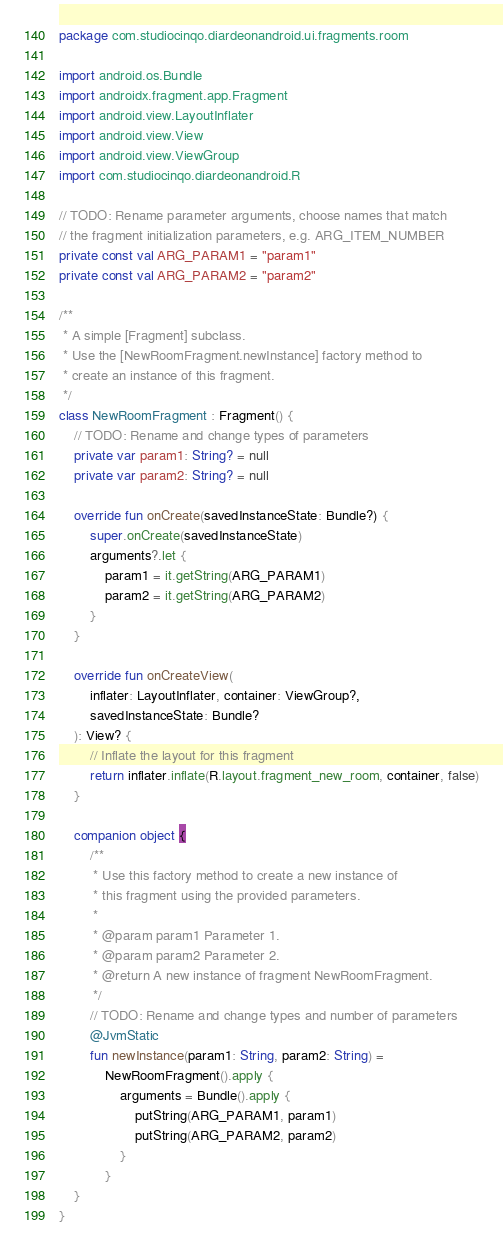Convert code to text. <code><loc_0><loc_0><loc_500><loc_500><_Kotlin_>package com.studiocinqo.diardeonandroid.ui.fragments.room

import android.os.Bundle
import androidx.fragment.app.Fragment
import android.view.LayoutInflater
import android.view.View
import android.view.ViewGroup
import com.studiocinqo.diardeonandroid.R

// TODO: Rename parameter arguments, choose names that match
// the fragment initialization parameters, e.g. ARG_ITEM_NUMBER
private const val ARG_PARAM1 = "param1"
private const val ARG_PARAM2 = "param2"

/**
 * A simple [Fragment] subclass.
 * Use the [NewRoomFragment.newInstance] factory method to
 * create an instance of this fragment.
 */
class NewRoomFragment : Fragment() {
    // TODO: Rename and change types of parameters
    private var param1: String? = null
    private var param2: String? = null

    override fun onCreate(savedInstanceState: Bundle?) {
        super.onCreate(savedInstanceState)
        arguments?.let {
            param1 = it.getString(ARG_PARAM1)
            param2 = it.getString(ARG_PARAM2)
        }
    }

    override fun onCreateView(
        inflater: LayoutInflater, container: ViewGroup?,
        savedInstanceState: Bundle?
    ): View? {
        // Inflate the layout for this fragment
        return inflater.inflate(R.layout.fragment_new_room, container, false)
    }

    companion object {
        /**
         * Use this factory method to create a new instance of
         * this fragment using the provided parameters.
         *
         * @param param1 Parameter 1.
         * @param param2 Parameter 2.
         * @return A new instance of fragment NewRoomFragment.
         */
        // TODO: Rename and change types and number of parameters
        @JvmStatic
        fun newInstance(param1: String, param2: String) =
            NewRoomFragment().apply {
                arguments = Bundle().apply {
                    putString(ARG_PARAM1, param1)
                    putString(ARG_PARAM2, param2)
                }
            }
    }
}</code> 